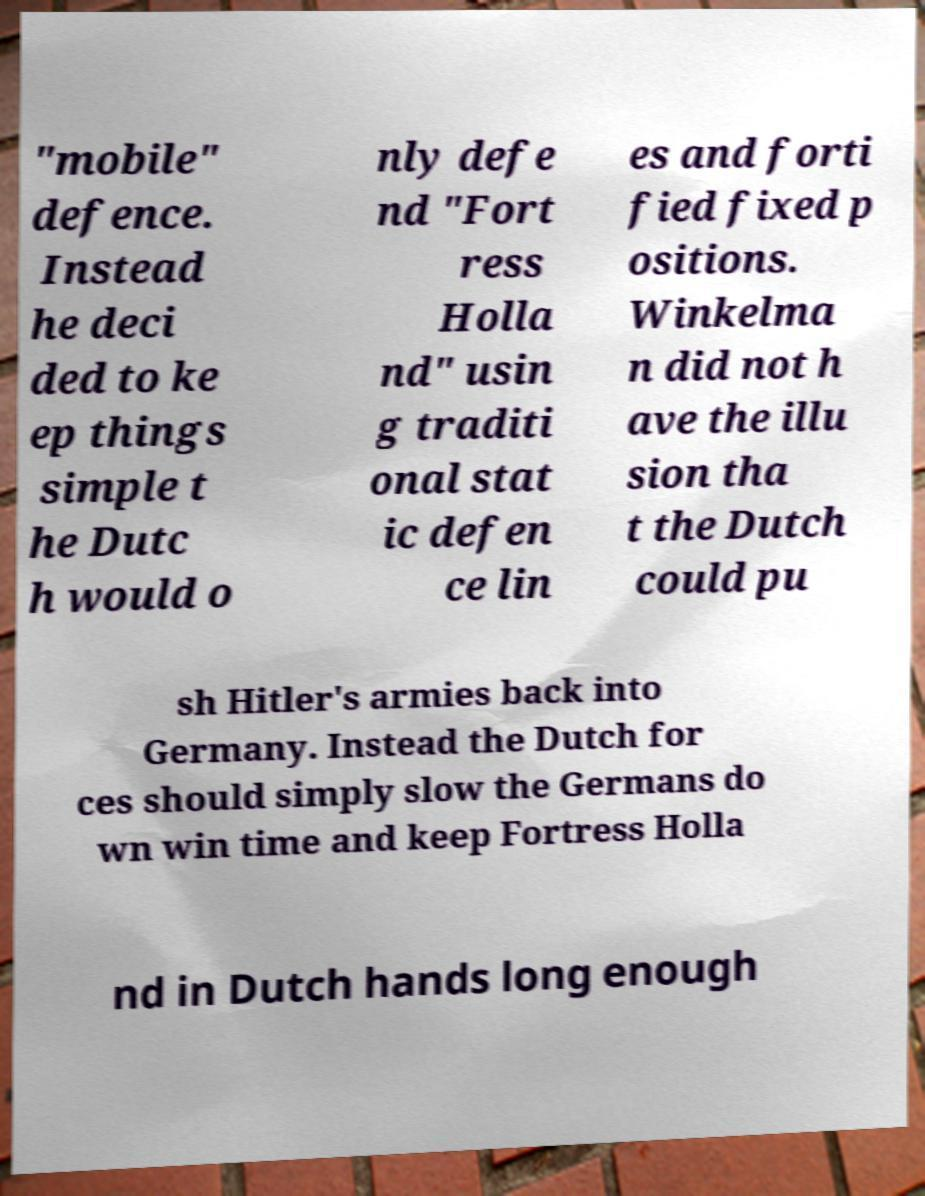There's text embedded in this image that I need extracted. Can you transcribe it verbatim? "mobile" defence. Instead he deci ded to ke ep things simple t he Dutc h would o nly defe nd "Fort ress Holla nd" usin g traditi onal stat ic defen ce lin es and forti fied fixed p ositions. Winkelma n did not h ave the illu sion tha t the Dutch could pu sh Hitler's armies back into Germany. Instead the Dutch for ces should simply slow the Germans do wn win time and keep Fortress Holla nd in Dutch hands long enough 